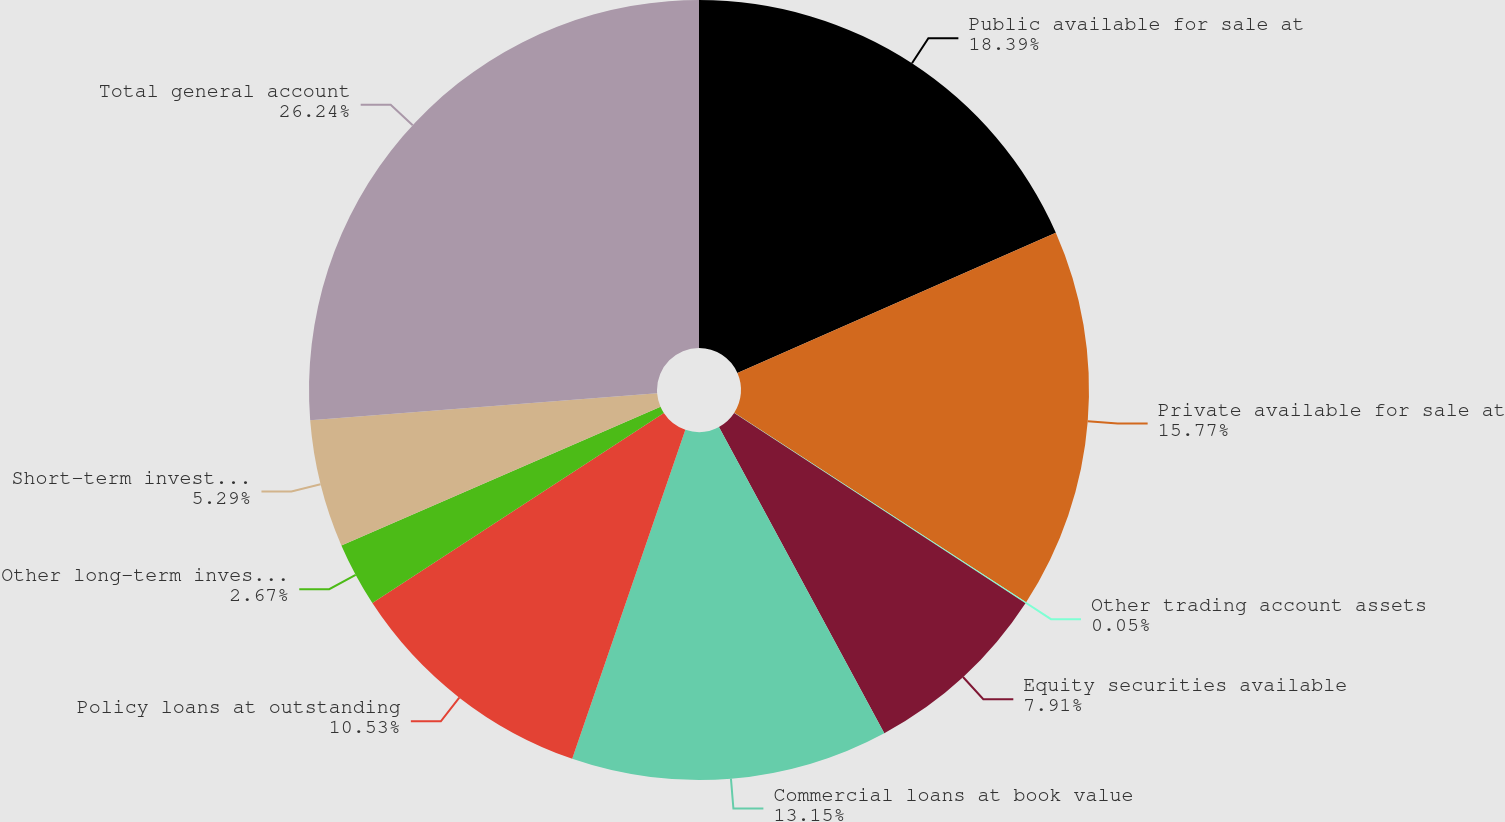Convert chart to OTSL. <chart><loc_0><loc_0><loc_500><loc_500><pie_chart><fcel>Public available for sale at<fcel>Private available for sale at<fcel>Other trading account assets<fcel>Equity securities available<fcel>Commercial loans at book value<fcel>Policy loans at outstanding<fcel>Other long-term investments(1)<fcel>Short-term investments(2)<fcel>Total general account<nl><fcel>18.39%<fcel>15.77%<fcel>0.05%<fcel>7.91%<fcel>13.15%<fcel>10.53%<fcel>2.67%<fcel>5.29%<fcel>26.24%<nl></chart> 